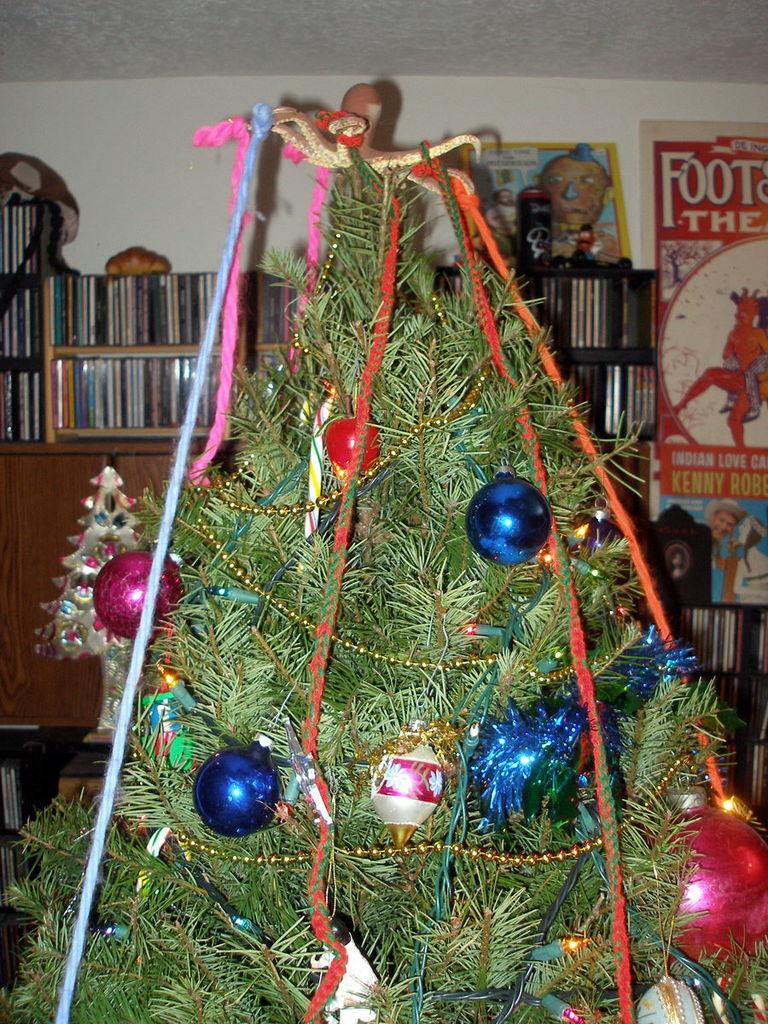How would you summarize this image in a sentence or two? In this picture I can see a inner view of a room and I can see a christmas tree and I can see few decorative balls and lighting to the tree and couple of posters with some text and I can see few books in the shelf. 